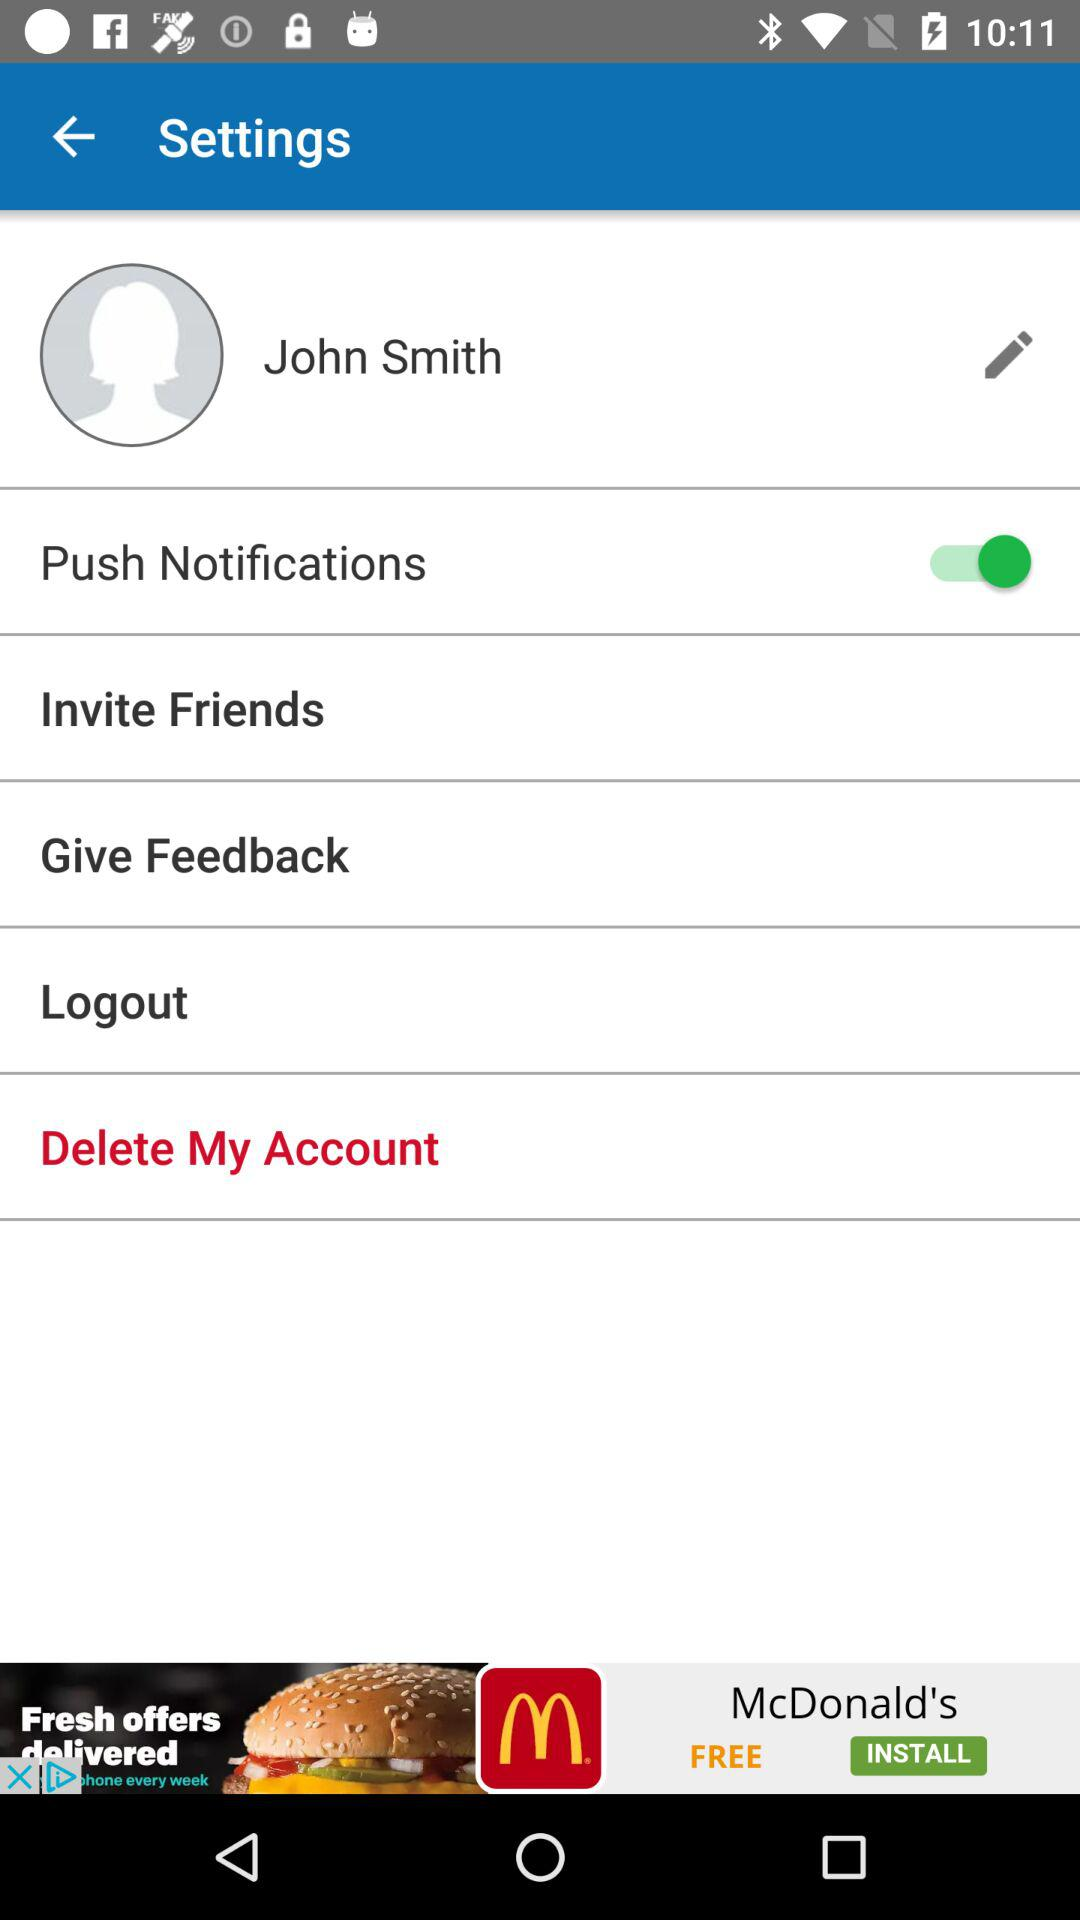What is the login name? The login name is John Smith. 